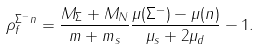Convert formula to latex. <formula><loc_0><loc_0><loc_500><loc_500>\rho _ { f } ^ { \Sigma ^ { - } n } = \frac { M _ { \Sigma } + M _ { N } } { m + m _ { s } } \frac { \mu ( \Sigma ^ { - } ) - \mu ( n ) } { \mu _ { s } + 2 \mu _ { d } } - 1 .</formula> 